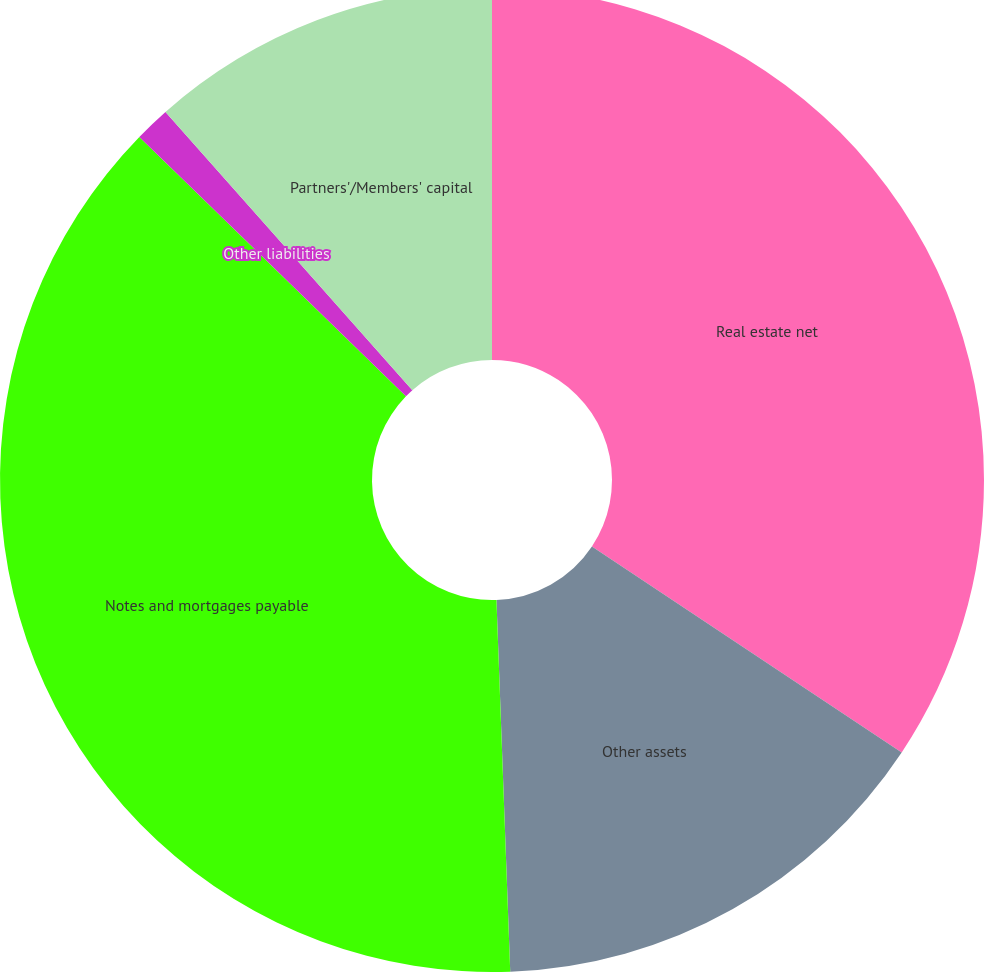Convert chart. <chart><loc_0><loc_0><loc_500><loc_500><pie_chart><fcel>Real estate net<fcel>Other assets<fcel>Notes and mortgages payable<fcel>Other liabilities<fcel>Partners'/Members' capital<nl><fcel>34.34%<fcel>15.07%<fcel>37.87%<fcel>1.17%<fcel>11.55%<nl></chart> 